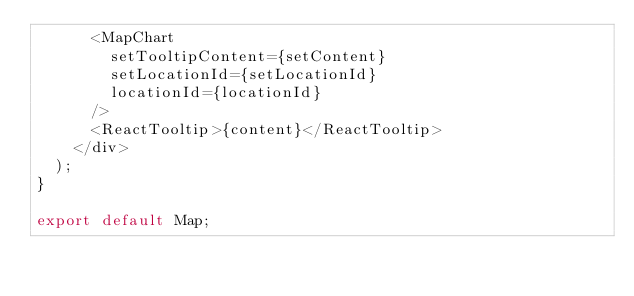<code> <loc_0><loc_0><loc_500><loc_500><_JavaScript_>      <MapChart
        setTooltipContent={setContent}
        setLocationId={setLocationId}
        locationId={locationId}
      />
      <ReactTooltip>{content}</ReactTooltip>
    </div>
  );
}

export default Map;
</code> 